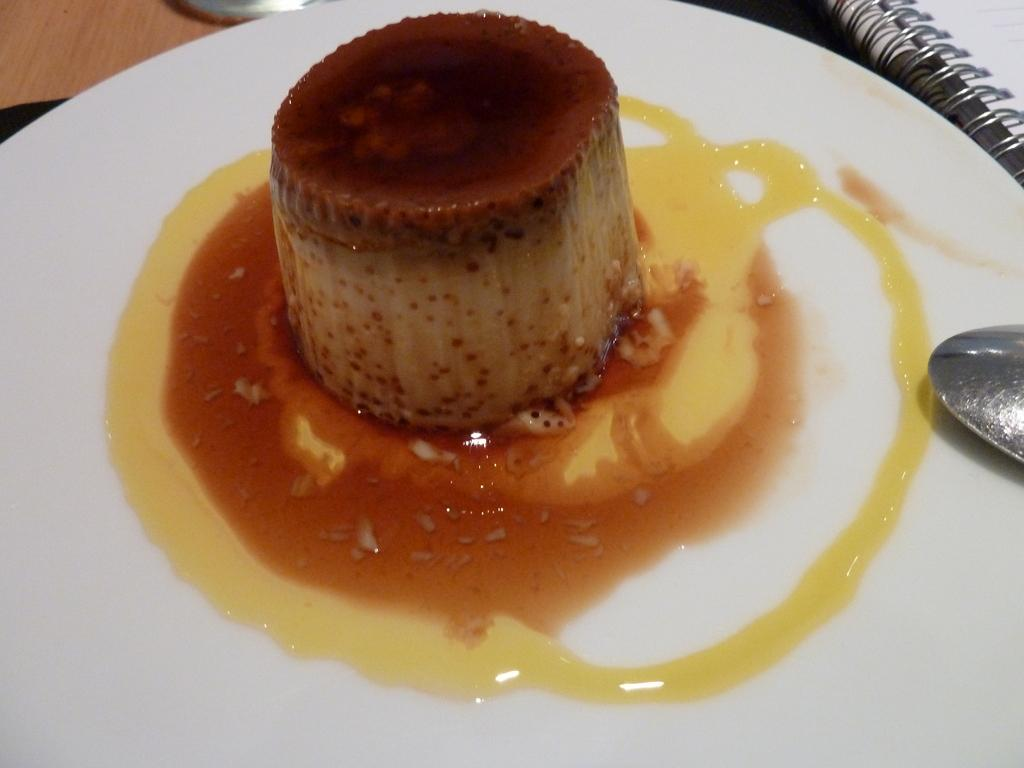What piece of furniture is present in the image? There is a table in the image. What object is placed on the table? There is a book on the table. What type of dishware is on the table? There is a white color plate on the table. What utensil is placed on the plate? There is a spoon on the plate. What is on the spoon? There is a dish on the plate. How does the cart attack the book in the image? There is no cart present in the image, and therefore no such attack can be observed. 